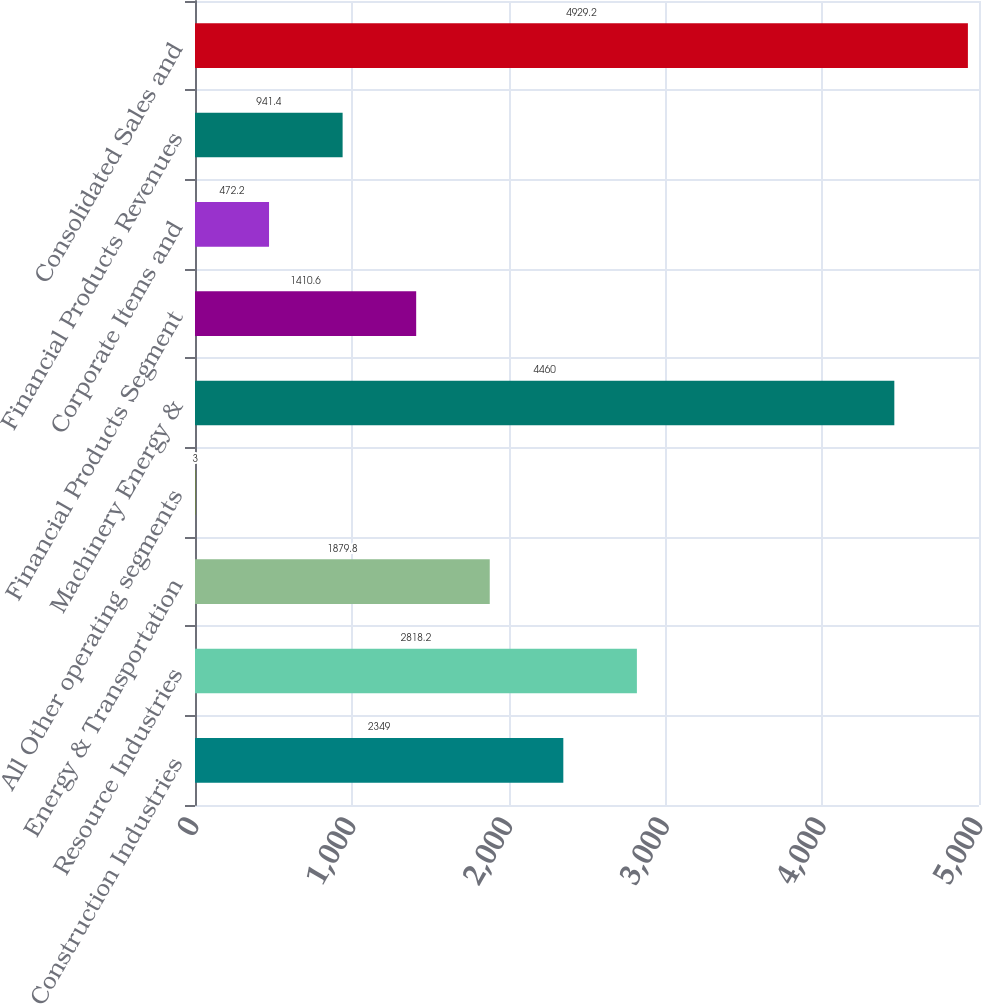Convert chart to OTSL. <chart><loc_0><loc_0><loc_500><loc_500><bar_chart><fcel>Construction Industries<fcel>Resource Industries<fcel>Energy & Transportation<fcel>All Other operating segments<fcel>Machinery Energy &<fcel>Financial Products Segment<fcel>Corporate Items and<fcel>Financial Products Revenues<fcel>Consolidated Sales and<nl><fcel>2349<fcel>2818.2<fcel>1879.8<fcel>3<fcel>4460<fcel>1410.6<fcel>472.2<fcel>941.4<fcel>4929.2<nl></chart> 